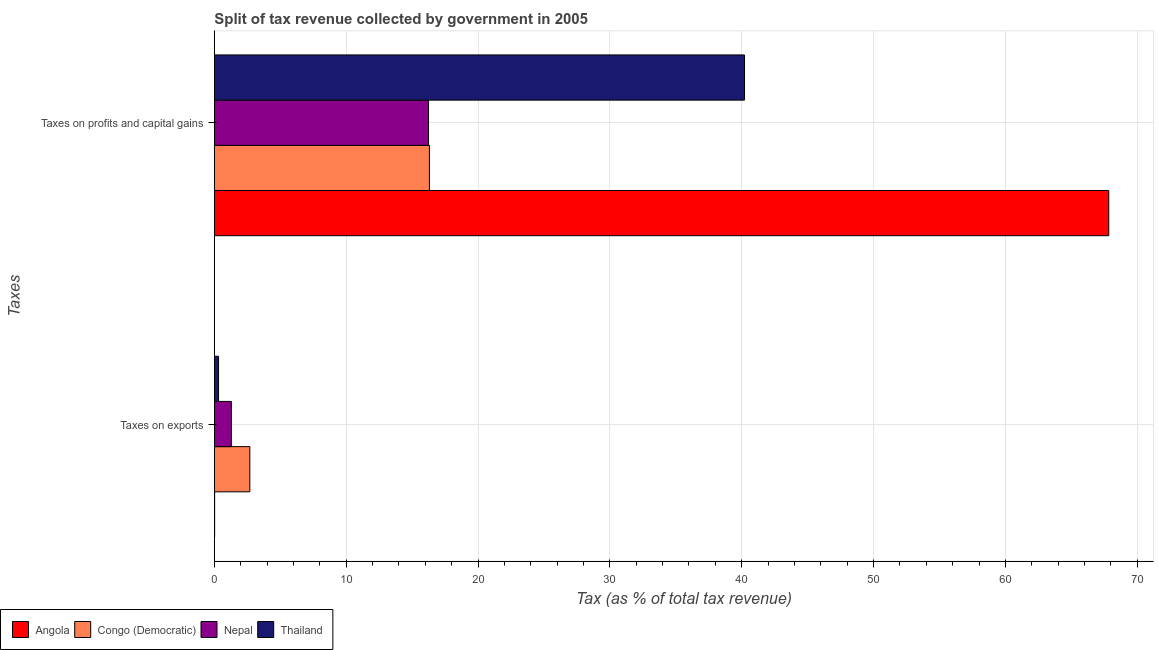How many groups of bars are there?
Give a very brief answer. 2. Are the number of bars per tick equal to the number of legend labels?
Your answer should be very brief. Yes. Are the number of bars on each tick of the Y-axis equal?
Provide a short and direct response. Yes. How many bars are there on the 1st tick from the bottom?
Make the answer very short. 4. What is the label of the 1st group of bars from the top?
Give a very brief answer. Taxes on profits and capital gains. What is the percentage of revenue obtained from taxes on exports in Congo (Democratic)?
Provide a short and direct response. 2.69. Across all countries, what is the maximum percentage of revenue obtained from taxes on exports?
Offer a very short reply. 2.69. Across all countries, what is the minimum percentage of revenue obtained from taxes on exports?
Offer a very short reply. 0.02. In which country was the percentage of revenue obtained from taxes on profits and capital gains maximum?
Give a very brief answer. Angola. In which country was the percentage of revenue obtained from taxes on profits and capital gains minimum?
Provide a succinct answer. Nepal. What is the total percentage of revenue obtained from taxes on profits and capital gains in the graph?
Provide a succinct answer. 140.61. What is the difference between the percentage of revenue obtained from taxes on exports in Congo (Democratic) and that in Angola?
Make the answer very short. 2.67. What is the difference between the percentage of revenue obtained from taxes on profits and capital gains in Angola and the percentage of revenue obtained from taxes on exports in Nepal?
Provide a short and direct response. 66.55. What is the average percentage of revenue obtained from taxes on exports per country?
Make the answer very short. 1.08. What is the difference between the percentage of revenue obtained from taxes on exports and percentage of revenue obtained from taxes on profits and capital gains in Nepal?
Keep it short and to the point. -14.96. What is the ratio of the percentage of revenue obtained from taxes on exports in Thailand to that in Congo (Democratic)?
Provide a short and direct response. 0.12. Is the percentage of revenue obtained from taxes on profits and capital gains in Angola less than that in Nepal?
Provide a short and direct response. No. In how many countries, is the percentage of revenue obtained from taxes on profits and capital gains greater than the average percentage of revenue obtained from taxes on profits and capital gains taken over all countries?
Keep it short and to the point. 2. What does the 2nd bar from the top in Taxes on profits and capital gains represents?
Keep it short and to the point. Nepal. What does the 3rd bar from the bottom in Taxes on profits and capital gains represents?
Provide a short and direct response. Nepal. How many bars are there?
Your answer should be very brief. 8. Are all the bars in the graph horizontal?
Your response must be concise. Yes. Are the values on the major ticks of X-axis written in scientific E-notation?
Your answer should be very brief. No. Does the graph contain grids?
Give a very brief answer. Yes. Where does the legend appear in the graph?
Ensure brevity in your answer.  Bottom left. How many legend labels are there?
Provide a succinct answer. 4. How are the legend labels stacked?
Your answer should be very brief. Horizontal. What is the title of the graph?
Ensure brevity in your answer.  Split of tax revenue collected by government in 2005. What is the label or title of the X-axis?
Offer a terse response. Tax (as % of total tax revenue). What is the label or title of the Y-axis?
Give a very brief answer. Taxes. What is the Tax (as % of total tax revenue) of Angola in Taxes on exports?
Offer a terse response. 0.02. What is the Tax (as % of total tax revenue) in Congo (Democratic) in Taxes on exports?
Offer a very short reply. 2.69. What is the Tax (as % of total tax revenue) of Nepal in Taxes on exports?
Ensure brevity in your answer.  1.29. What is the Tax (as % of total tax revenue) of Thailand in Taxes on exports?
Provide a short and direct response. 0.32. What is the Tax (as % of total tax revenue) in Angola in Taxes on profits and capital gains?
Your response must be concise. 67.84. What is the Tax (as % of total tax revenue) of Congo (Democratic) in Taxes on profits and capital gains?
Offer a very short reply. 16.31. What is the Tax (as % of total tax revenue) in Nepal in Taxes on profits and capital gains?
Offer a terse response. 16.25. What is the Tax (as % of total tax revenue) of Thailand in Taxes on profits and capital gains?
Offer a terse response. 40.21. Across all Taxes, what is the maximum Tax (as % of total tax revenue) in Angola?
Provide a short and direct response. 67.84. Across all Taxes, what is the maximum Tax (as % of total tax revenue) in Congo (Democratic)?
Your answer should be compact. 16.31. Across all Taxes, what is the maximum Tax (as % of total tax revenue) of Nepal?
Give a very brief answer. 16.25. Across all Taxes, what is the maximum Tax (as % of total tax revenue) of Thailand?
Ensure brevity in your answer.  40.21. Across all Taxes, what is the minimum Tax (as % of total tax revenue) in Angola?
Make the answer very short. 0.02. Across all Taxes, what is the minimum Tax (as % of total tax revenue) of Congo (Democratic)?
Provide a short and direct response. 2.69. Across all Taxes, what is the minimum Tax (as % of total tax revenue) in Nepal?
Provide a succinct answer. 1.29. Across all Taxes, what is the minimum Tax (as % of total tax revenue) of Thailand?
Provide a short and direct response. 0.32. What is the total Tax (as % of total tax revenue) of Angola in the graph?
Make the answer very short. 67.86. What is the total Tax (as % of total tax revenue) in Congo (Democratic) in the graph?
Make the answer very short. 19.01. What is the total Tax (as % of total tax revenue) in Nepal in the graph?
Your response must be concise. 17.54. What is the total Tax (as % of total tax revenue) of Thailand in the graph?
Make the answer very short. 40.53. What is the difference between the Tax (as % of total tax revenue) in Angola in Taxes on exports and that in Taxes on profits and capital gains?
Provide a short and direct response. -67.82. What is the difference between the Tax (as % of total tax revenue) of Congo (Democratic) in Taxes on exports and that in Taxes on profits and capital gains?
Provide a succinct answer. -13.62. What is the difference between the Tax (as % of total tax revenue) of Nepal in Taxes on exports and that in Taxes on profits and capital gains?
Keep it short and to the point. -14.96. What is the difference between the Tax (as % of total tax revenue) in Thailand in Taxes on exports and that in Taxes on profits and capital gains?
Your answer should be very brief. -39.89. What is the difference between the Tax (as % of total tax revenue) of Angola in Taxes on exports and the Tax (as % of total tax revenue) of Congo (Democratic) in Taxes on profits and capital gains?
Provide a succinct answer. -16.29. What is the difference between the Tax (as % of total tax revenue) of Angola in Taxes on exports and the Tax (as % of total tax revenue) of Nepal in Taxes on profits and capital gains?
Keep it short and to the point. -16.22. What is the difference between the Tax (as % of total tax revenue) of Angola in Taxes on exports and the Tax (as % of total tax revenue) of Thailand in Taxes on profits and capital gains?
Provide a short and direct response. -40.19. What is the difference between the Tax (as % of total tax revenue) in Congo (Democratic) in Taxes on exports and the Tax (as % of total tax revenue) in Nepal in Taxes on profits and capital gains?
Keep it short and to the point. -13.55. What is the difference between the Tax (as % of total tax revenue) of Congo (Democratic) in Taxes on exports and the Tax (as % of total tax revenue) of Thailand in Taxes on profits and capital gains?
Your answer should be very brief. -37.52. What is the difference between the Tax (as % of total tax revenue) of Nepal in Taxes on exports and the Tax (as % of total tax revenue) of Thailand in Taxes on profits and capital gains?
Keep it short and to the point. -38.92. What is the average Tax (as % of total tax revenue) of Angola per Taxes?
Your answer should be compact. 33.93. What is the average Tax (as % of total tax revenue) of Congo (Democratic) per Taxes?
Keep it short and to the point. 9.5. What is the average Tax (as % of total tax revenue) of Nepal per Taxes?
Your response must be concise. 8.77. What is the average Tax (as % of total tax revenue) of Thailand per Taxes?
Give a very brief answer. 20.26. What is the difference between the Tax (as % of total tax revenue) of Angola and Tax (as % of total tax revenue) of Congo (Democratic) in Taxes on exports?
Keep it short and to the point. -2.67. What is the difference between the Tax (as % of total tax revenue) in Angola and Tax (as % of total tax revenue) in Nepal in Taxes on exports?
Keep it short and to the point. -1.27. What is the difference between the Tax (as % of total tax revenue) of Angola and Tax (as % of total tax revenue) of Thailand in Taxes on exports?
Keep it short and to the point. -0.3. What is the difference between the Tax (as % of total tax revenue) of Congo (Democratic) and Tax (as % of total tax revenue) of Nepal in Taxes on exports?
Your answer should be very brief. 1.4. What is the difference between the Tax (as % of total tax revenue) in Congo (Democratic) and Tax (as % of total tax revenue) in Thailand in Taxes on exports?
Your response must be concise. 2.37. What is the difference between the Tax (as % of total tax revenue) of Nepal and Tax (as % of total tax revenue) of Thailand in Taxes on exports?
Provide a short and direct response. 0.97. What is the difference between the Tax (as % of total tax revenue) of Angola and Tax (as % of total tax revenue) of Congo (Democratic) in Taxes on profits and capital gains?
Your answer should be compact. 51.53. What is the difference between the Tax (as % of total tax revenue) of Angola and Tax (as % of total tax revenue) of Nepal in Taxes on profits and capital gains?
Your answer should be very brief. 51.6. What is the difference between the Tax (as % of total tax revenue) of Angola and Tax (as % of total tax revenue) of Thailand in Taxes on profits and capital gains?
Provide a short and direct response. 27.63. What is the difference between the Tax (as % of total tax revenue) of Congo (Democratic) and Tax (as % of total tax revenue) of Nepal in Taxes on profits and capital gains?
Offer a very short reply. 0.07. What is the difference between the Tax (as % of total tax revenue) of Congo (Democratic) and Tax (as % of total tax revenue) of Thailand in Taxes on profits and capital gains?
Offer a very short reply. -23.9. What is the difference between the Tax (as % of total tax revenue) in Nepal and Tax (as % of total tax revenue) in Thailand in Taxes on profits and capital gains?
Offer a very short reply. -23.96. What is the ratio of the Tax (as % of total tax revenue) of Congo (Democratic) in Taxes on exports to that in Taxes on profits and capital gains?
Your response must be concise. 0.17. What is the ratio of the Tax (as % of total tax revenue) of Nepal in Taxes on exports to that in Taxes on profits and capital gains?
Offer a very short reply. 0.08. What is the ratio of the Tax (as % of total tax revenue) of Thailand in Taxes on exports to that in Taxes on profits and capital gains?
Your answer should be compact. 0.01. What is the difference between the highest and the second highest Tax (as % of total tax revenue) of Angola?
Provide a succinct answer. 67.82. What is the difference between the highest and the second highest Tax (as % of total tax revenue) in Congo (Democratic)?
Make the answer very short. 13.62. What is the difference between the highest and the second highest Tax (as % of total tax revenue) in Nepal?
Your answer should be very brief. 14.96. What is the difference between the highest and the second highest Tax (as % of total tax revenue) in Thailand?
Give a very brief answer. 39.89. What is the difference between the highest and the lowest Tax (as % of total tax revenue) in Angola?
Give a very brief answer. 67.82. What is the difference between the highest and the lowest Tax (as % of total tax revenue) of Congo (Democratic)?
Ensure brevity in your answer.  13.62. What is the difference between the highest and the lowest Tax (as % of total tax revenue) of Nepal?
Offer a terse response. 14.96. What is the difference between the highest and the lowest Tax (as % of total tax revenue) of Thailand?
Ensure brevity in your answer.  39.89. 